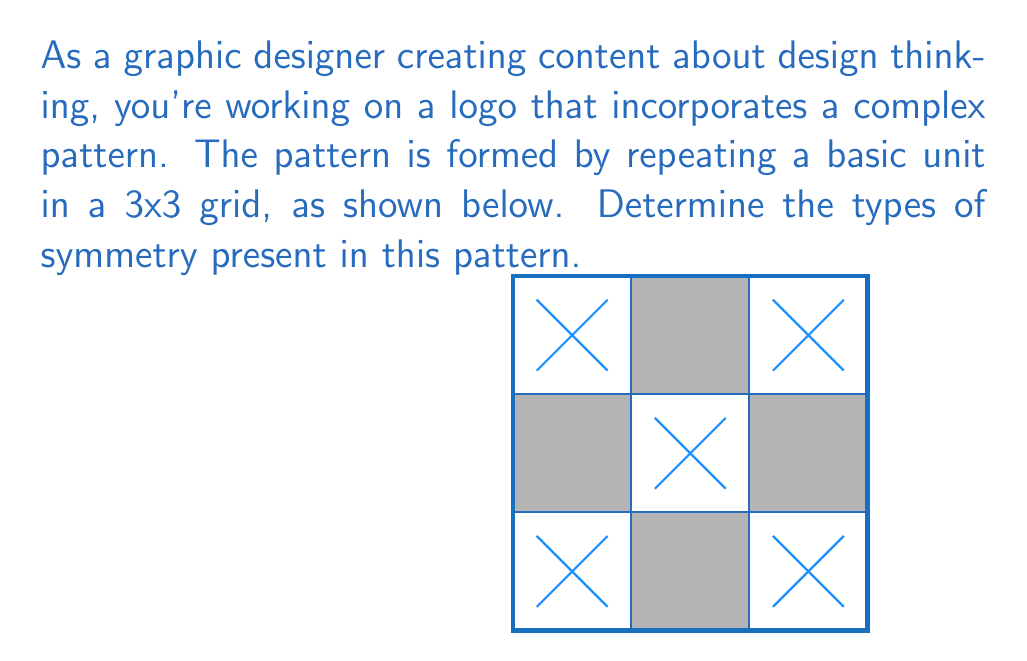Show me your answer to this math problem. To determine the symmetry of this pattern, we need to analyze it for different types of symmetry:

1. Rotational symmetry:
   - The pattern remains unchanged when rotated 180° around its center.
   - This is 2-fold rotational symmetry.

2. Reflectional symmetry:
   - Vertical axis: The pattern is symmetrical about the vertical line through its center.
   - Horizontal axis: The pattern is symmetrical about the horizontal line through its center.
   - Diagonal axes: The pattern is symmetrical about both diagonal lines (top-left to bottom-right and top-right to bottom-left).

3. Translational symmetry:
   - The basic unit repeats in a 3x3 grid, exhibiting translational symmetry.

4. Glide reflection:
   - There is no glide reflection symmetry in this pattern.

In total, the pattern exhibits:
- 2-fold rotational symmetry
- 4 lines of reflectional symmetry (1 vertical, 1 horizontal, 2 diagonal)
- Translational symmetry
Answer: 2-fold rotational, 4 reflectional (1 vertical, 1 horizontal, 2 diagonal), translational 